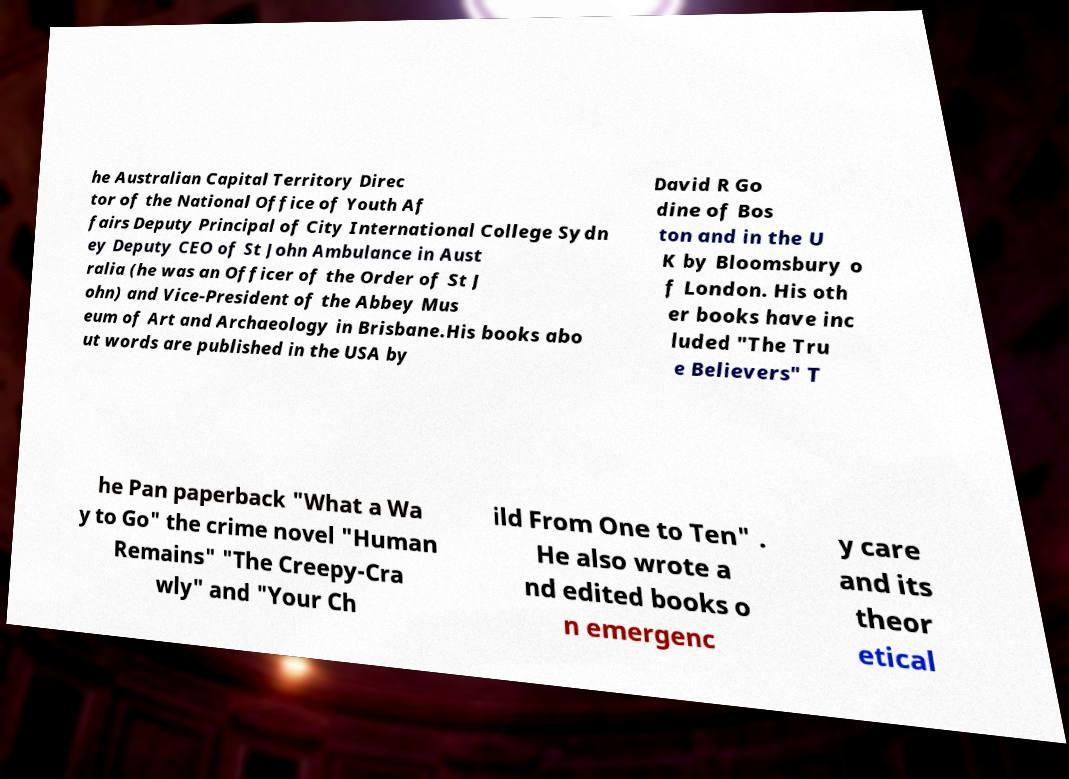Can you accurately transcribe the text from the provided image for me? he Australian Capital Territory Direc tor of the National Office of Youth Af fairs Deputy Principal of City International College Sydn ey Deputy CEO of St John Ambulance in Aust ralia (he was an Officer of the Order of St J ohn) and Vice-President of the Abbey Mus eum of Art and Archaeology in Brisbane.His books abo ut words are published in the USA by David R Go dine of Bos ton and in the U K by Bloomsbury o f London. His oth er books have inc luded "The Tru e Believers" T he Pan paperback "What a Wa y to Go" the crime novel "Human Remains" "The Creepy-Cra wly" and "Your Ch ild From One to Ten" . He also wrote a nd edited books o n emergenc y care and its theor etical 